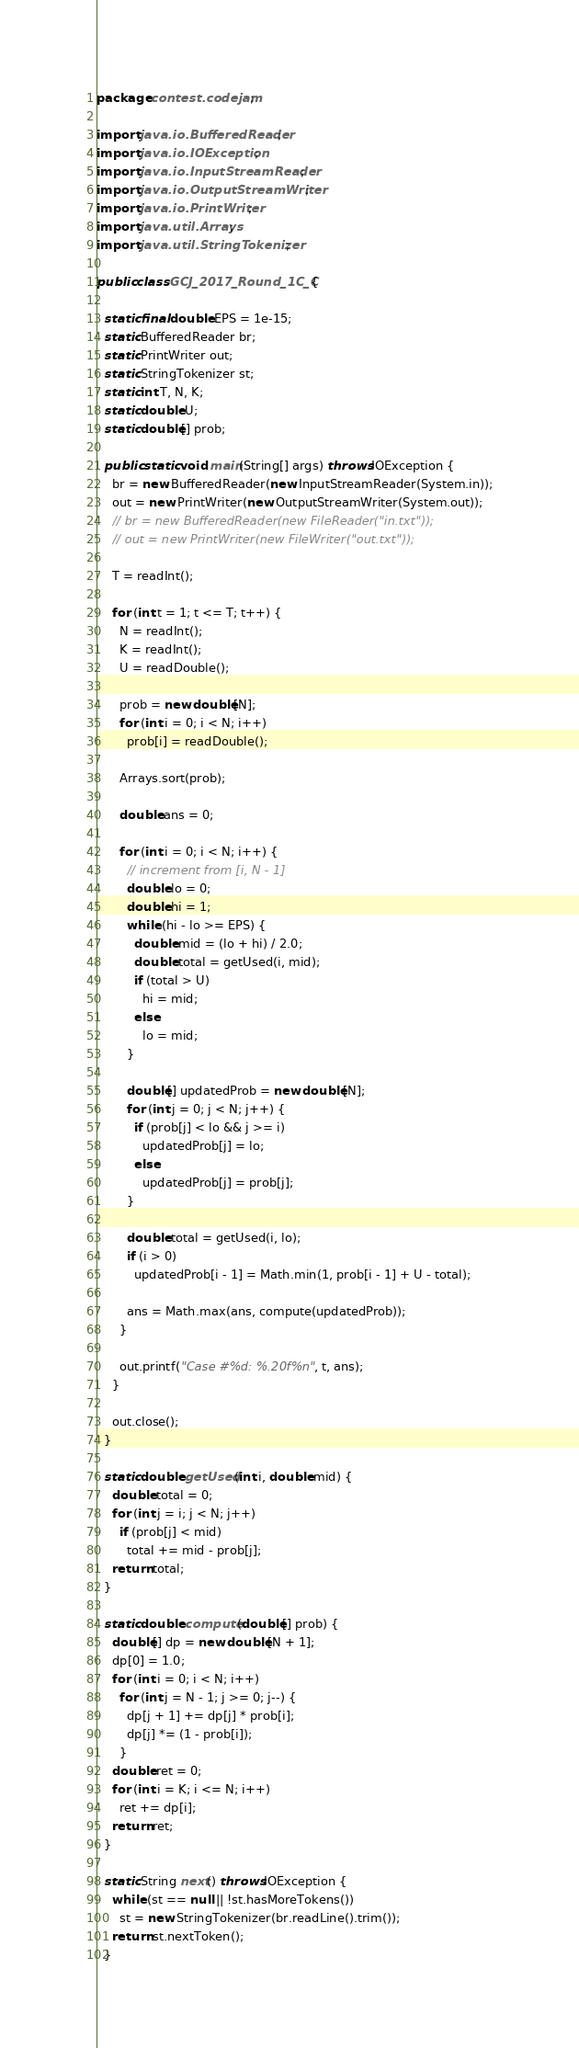<code> <loc_0><loc_0><loc_500><loc_500><_Java_>package contest.codejam;

import java.io.BufferedReader;
import java.io.IOException;
import java.io.InputStreamReader;
import java.io.OutputStreamWriter;
import java.io.PrintWriter;
import java.util.Arrays;
import java.util.StringTokenizer;

public class GCJ_2017_Round_1C_C {

  static final double EPS = 1e-15;
  static BufferedReader br;
  static PrintWriter out;
  static StringTokenizer st;
  static int T, N, K;
  static double U;
  static double[] prob;

  public static void main(String[] args) throws IOException {
    br = new BufferedReader(new InputStreamReader(System.in));
    out = new PrintWriter(new OutputStreamWriter(System.out));
    // br = new BufferedReader(new FileReader("in.txt"));
    // out = new PrintWriter(new FileWriter("out.txt"));

    T = readInt();

    for (int t = 1; t <= T; t++) {
      N = readInt();
      K = readInt();
      U = readDouble();

      prob = new double[N];
      for (int i = 0; i < N; i++)
        prob[i] = readDouble();

      Arrays.sort(prob);

      double ans = 0;

      for (int i = 0; i < N; i++) {
        // increment from [i, N - 1]
        double lo = 0;
        double hi = 1;
        while (hi - lo >= EPS) {
          double mid = (lo + hi) / 2.0;
          double total = getUsed(i, mid);
          if (total > U)
            hi = mid;
          else
            lo = mid;
        }

        double[] updatedProb = new double[N];
        for (int j = 0; j < N; j++) {
          if (prob[j] < lo && j >= i)
            updatedProb[j] = lo;
          else
            updatedProb[j] = prob[j];
        }

        double total = getUsed(i, lo);
        if (i > 0)
          updatedProb[i - 1] = Math.min(1, prob[i - 1] + U - total);

        ans = Math.max(ans, compute(updatedProb));
      }

      out.printf("Case #%d: %.20f%n", t, ans);
    }

    out.close();
  }

  static double getUsed(int i, double mid) {
    double total = 0;
    for (int j = i; j < N; j++)
      if (prob[j] < mid)
        total += mid - prob[j];
    return total;
  }

  static double compute(double[] prob) {
    double[] dp = new double[N + 1];
    dp[0] = 1.0;
    for (int i = 0; i < N; i++)
      for (int j = N - 1; j >= 0; j--) {
        dp[j + 1] += dp[j] * prob[i];
        dp[j] *= (1 - prob[i]);
      }
    double ret = 0;
    for (int i = K; i <= N; i++)
      ret += dp[i];
    return ret;
  }

  static String next() throws IOException {
    while (st == null || !st.hasMoreTokens())
      st = new StringTokenizer(br.readLine().trim());
    return st.nextToken();
  }
</code> 